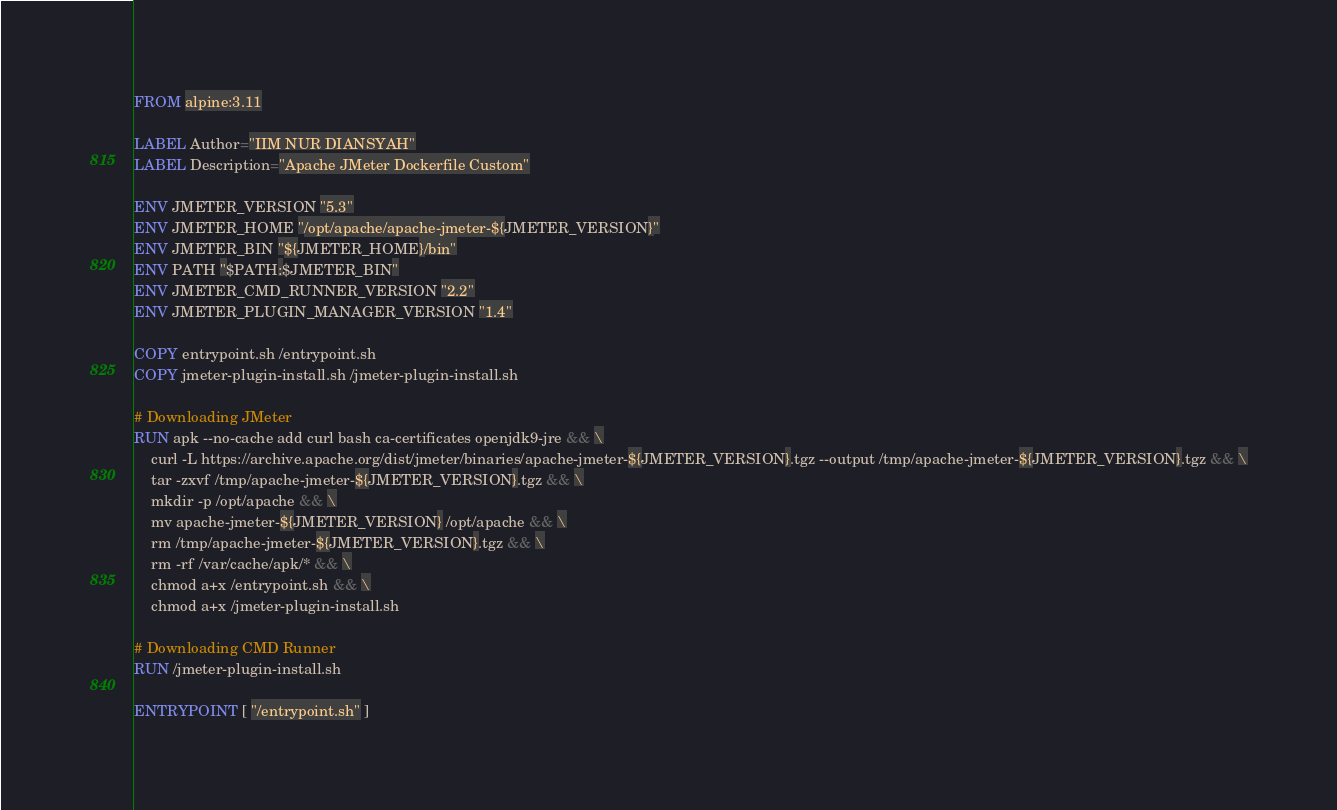Convert code to text. <code><loc_0><loc_0><loc_500><loc_500><_Dockerfile_>FROM alpine:3.11

LABEL Author="IIM NUR DIANSYAH"
LABEL Description="Apache JMeter Dockerfile Custom"

ENV JMETER_VERSION "5.3"
ENV JMETER_HOME "/opt/apache/apache-jmeter-${JMETER_VERSION}"
ENV JMETER_BIN "${JMETER_HOME}/bin"
ENV PATH "$PATH:$JMETER_BIN"
ENV JMETER_CMD_RUNNER_VERSION "2.2"
ENV JMETER_PLUGIN_MANAGER_VERSION "1.4"

COPY entrypoint.sh /entrypoint.sh
COPY jmeter-plugin-install.sh /jmeter-plugin-install.sh

# Downloading JMeter
RUN apk --no-cache add curl bash ca-certificates openjdk9-jre && \
    curl -L https://archive.apache.org/dist/jmeter/binaries/apache-jmeter-${JMETER_VERSION}.tgz --output /tmp/apache-jmeter-${JMETER_VERSION}.tgz && \
    tar -zxvf /tmp/apache-jmeter-${JMETER_VERSION}.tgz && \
    mkdir -p /opt/apache && \
    mv apache-jmeter-${JMETER_VERSION} /opt/apache && \
    rm /tmp/apache-jmeter-${JMETER_VERSION}.tgz && \
    rm -rf /var/cache/apk/* && \
    chmod a+x /entrypoint.sh && \
    chmod a+x /jmeter-plugin-install.sh

# Downloading CMD Runner
RUN /jmeter-plugin-install.sh

ENTRYPOINT [ "/entrypoint.sh" ]
</code> 